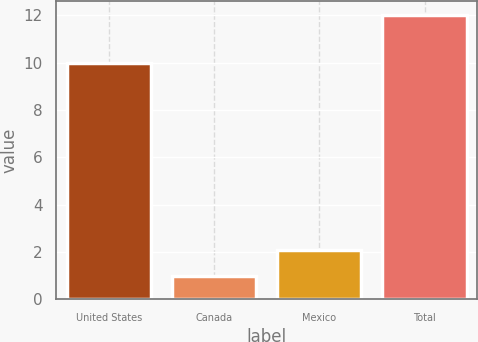<chart> <loc_0><loc_0><loc_500><loc_500><bar_chart><fcel>United States<fcel>Canada<fcel>Mexico<fcel>Total<nl><fcel>10<fcel>1<fcel>2.1<fcel>12<nl></chart> 